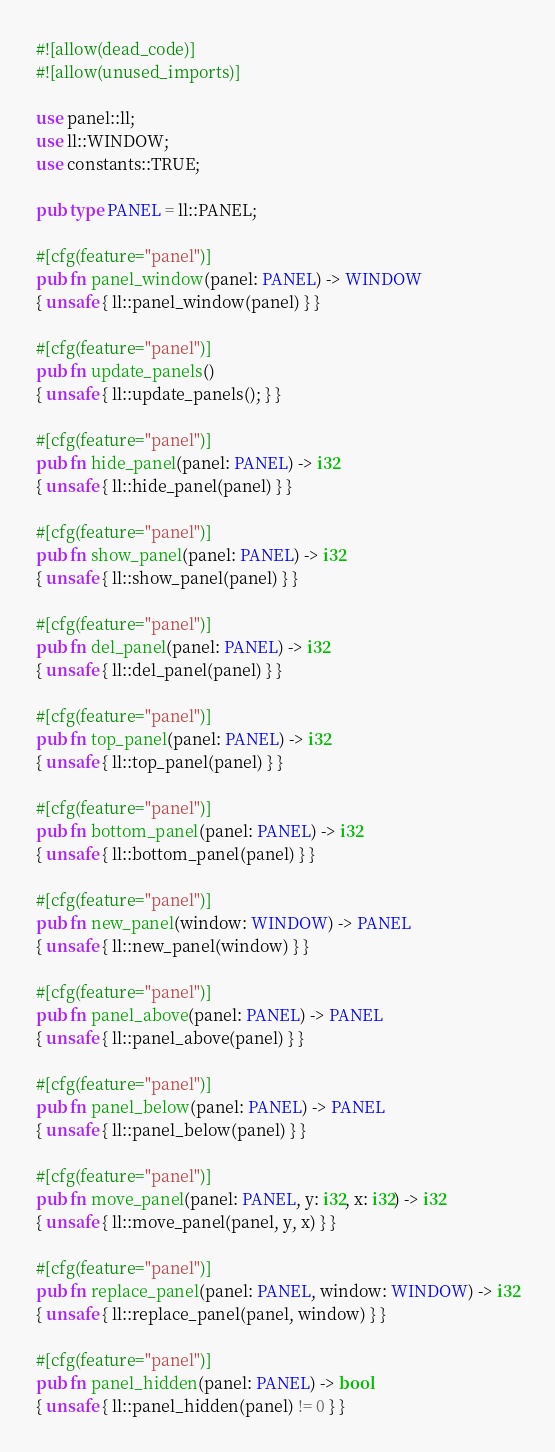Convert code to text. <code><loc_0><loc_0><loc_500><loc_500><_Rust_>#![allow(dead_code)]
#![allow(unused_imports)]

use panel::ll;
use ll::WINDOW;
use constants::TRUE;

pub type PANEL = ll::PANEL;

#[cfg(feature="panel")]
pub fn panel_window(panel: PANEL) -> WINDOW
{ unsafe { ll::panel_window(panel) } }

#[cfg(feature="panel")]
pub fn update_panels()
{ unsafe { ll::update_panels(); } }

#[cfg(feature="panel")]
pub fn hide_panel(panel: PANEL) -> i32
{ unsafe { ll::hide_panel(panel) } }

#[cfg(feature="panel")]
pub fn show_panel(panel: PANEL) -> i32
{ unsafe { ll::show_panel(panel) } }

#[cfg(feature="panel")]
pub fn del_panel(panel: PANEL) -> i32
{ unsafe { ll::del_panel(panel) } }

#[cfg(feature="panel")]
pub fn top_panel(panel: PANEL) -> i32
{ unsafe { ll::top_panel(panel) } }

#[cfg(feature="panel")]
pub fn bottom_panel(panel: PANEL) -> i32
{ unsafe { ll::bottom_panel(panel) } }

#[cfg(feature="panel")]
pub fn new_panel(window: WINDOW) -> PANEL
{ unsafe { ll::new_panel(window) } }

#[cfg(feature="panel")]
pub fn panel_above(panel: PANEL) -> PANEL
{ unsafe { ll::panel_above(panel) } }

#[cfg(feature="panel")]
pub fn panel_below(panel: PANEL) -> PANEL
{ unsafe { ll::panel_below(panel) } }

#[cfg(feature="panel")]
pub fn move_panel(panel: PANEL, y: i32, x: i32) -> i32
{ unsafe { ll::move_panel(panel, y, x) } }

#[cfg(feature="panel")]
pub fn replace_panel(panel: PANEL, window: WINDOW) -> i32
{ unsafe { ll::replace_panel(panel, window) } }

#[cfg(feature="panel")]
pub fn panel_hidden(panel: PANEL) -> bool
{ unsafe { ll::panel_hidden(panel) != 0 } }
</code> 